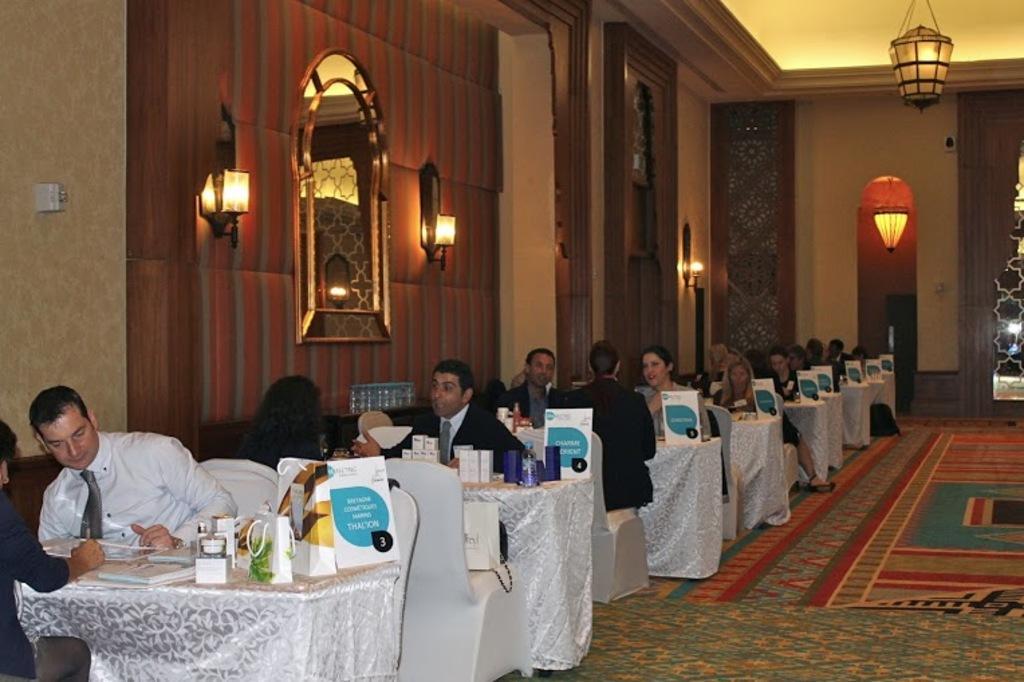Could you give a brief overview of what you see in this image? In this image, There is a floor which on that floor there is a carpet in red color, there are some table covered by a white cloth and there are some chairs in white color and there are some people sitting on the chairs, In the background there is a brown color wall and a window in yellow color, In the right side top there are some light in yellow color hanging on the roof. 